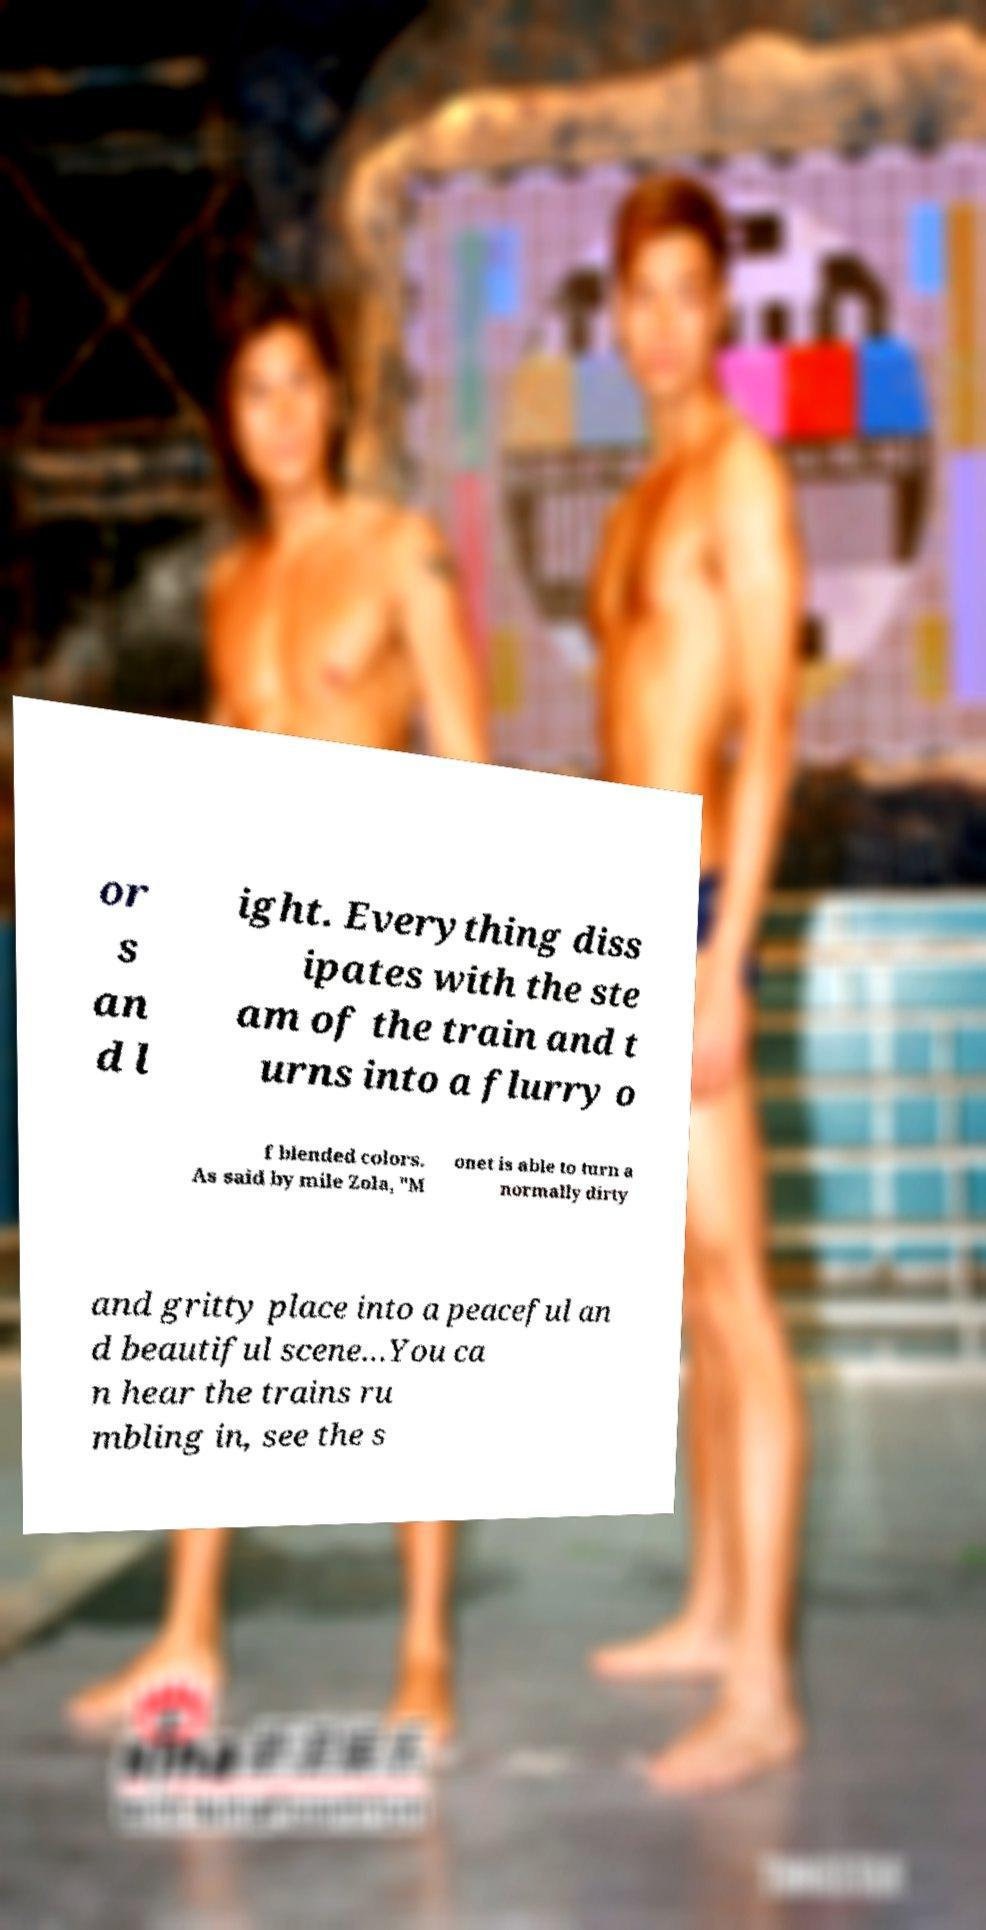What messages or text are displayed in this image? I need them in a readable, typed format. or s an d l ight. Everything diss ipates with the ste am of the train and t urns into a flurry o f blended colors. As said by mile Zola, "M onet is able to turn a normally dirty and gritty place into a peaceful an d beautiful scene…You ca n hear the trains ru mbling in, see the s 